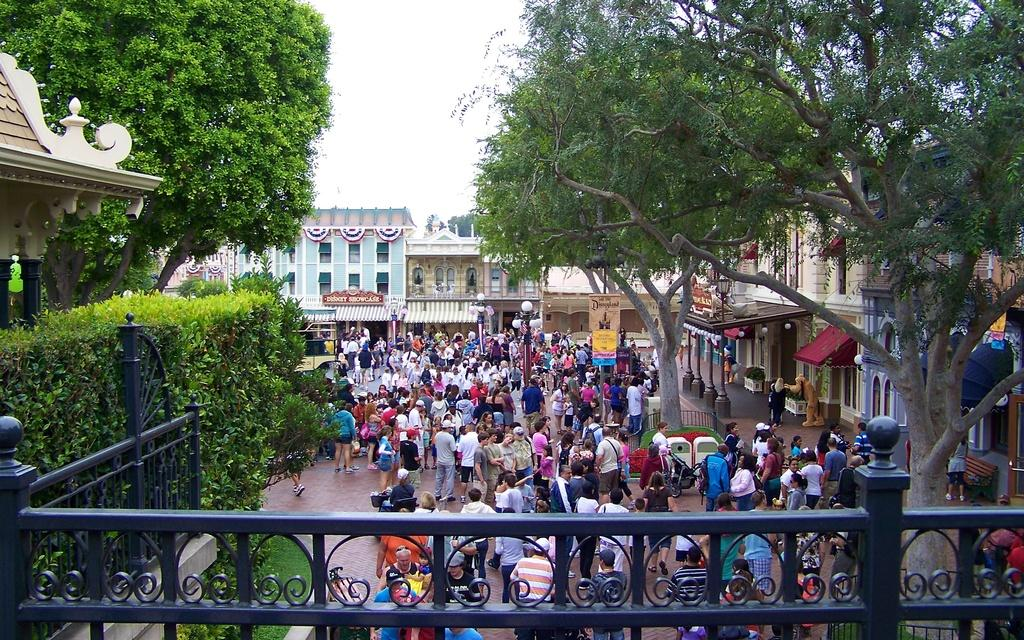What is the main subject of the image? There is a group of people in the middle of the image. What can be seen in the background of the image? There are houses in the background of the image. What type of vegetation is present in the image? There are green color trees in the image. What type of judgment is the judge making in the image? There is no judge present in the image, so it's not possible to determine any judgments being made. 